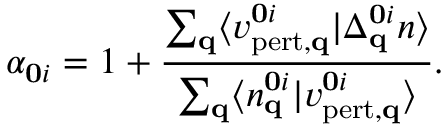Convert formula to latex. <formula><loc_0><loc_0><loc_500><loc_500>\alpha _ { 0 i } = 1 + \frac { \sum _ { q } \langle v _ { p e r t , q } ^ { 0 i } | \Delta _ { q } ^ { 0 i } n \rangle } { \sum _ { q } \langle n _ { q } ^ { 0 i } | v _ { p e r t , q } ^ { 0 i } \rangle } .</formula> 